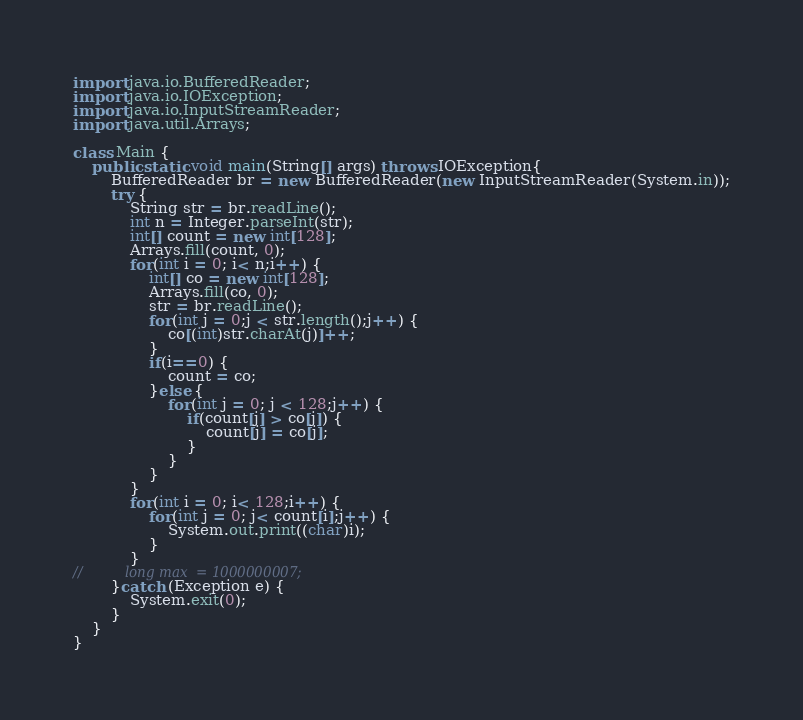<code> <loc_0><loc_0><loc_500><loc_500><_Java_>import java.io.BufferedReader;
import java.io.IOException;
import java.io.InputStreamReader;
import java.util.Arrays;

class Main {
	public static void main(String[] args) throws IOException{
		BufferedReader br = new BufferedReader(new InputStreamReader(System.in));
		try {
			String str = br.readLine();
			int n = Integer.parseInt(str);
			int[] count = new int[128];
			Arrays.fill(count, 0);
			for(int i = 0; i< n;i++) {
				int[] co = new int[128];
				Arrays.fill(co, 0);
				str = br.readLine();
				for(int j = 0;j < str.length();j++) {
					co[(int)str.charAt(j)]++;
				}
				if(i==0) {
					count = co;
				}else {
					for(int j = 0; j < 128;j++) {
						if(count[j] > co[j]) {
							count[j] = co[j];
						}
					}
				}
			}
			for(int i = 0; i< 128;i++) {
				for(int j = 0; j< count[i];j++) {
					System.out.print((char)i);
				}
			}
//			long max  = 1000000007;
		}catch (Exception e) {
			System.exit(0);
		}
	}
}
</code> 